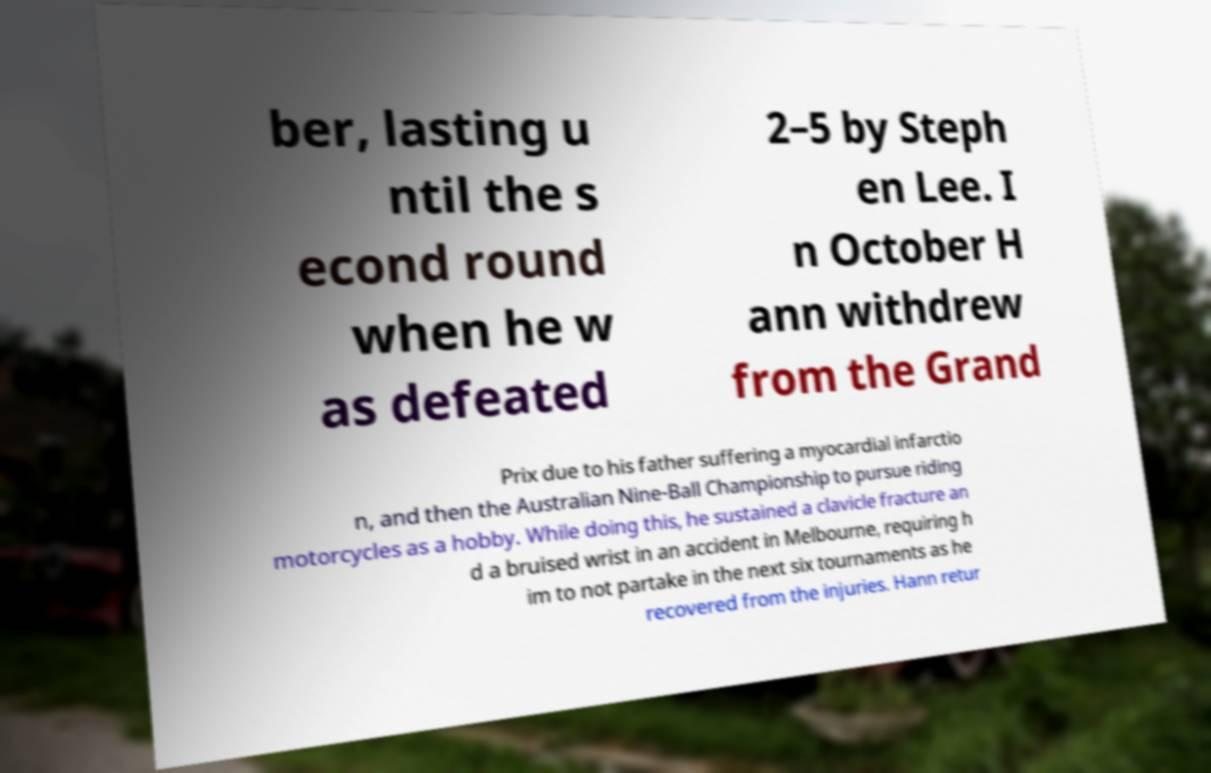Please identify and transcribe the text found in this image. ber, lasting u ntil the s econd round when he w as defeated 2–5 by Steph en Lee. I n October H ann withdrew from the Grand Prix due to his father suffering a myocardial infarctio n, and then the Australian Nine-Ball Championship to pursue riding motorcycles as a hobby. While doing this, he sustained a clavicle fracture an d a bruised wrist in an accident in Melbourne, requiring h im to not partake in the next six tournaments as he recovered from the injuries. Hann retur 